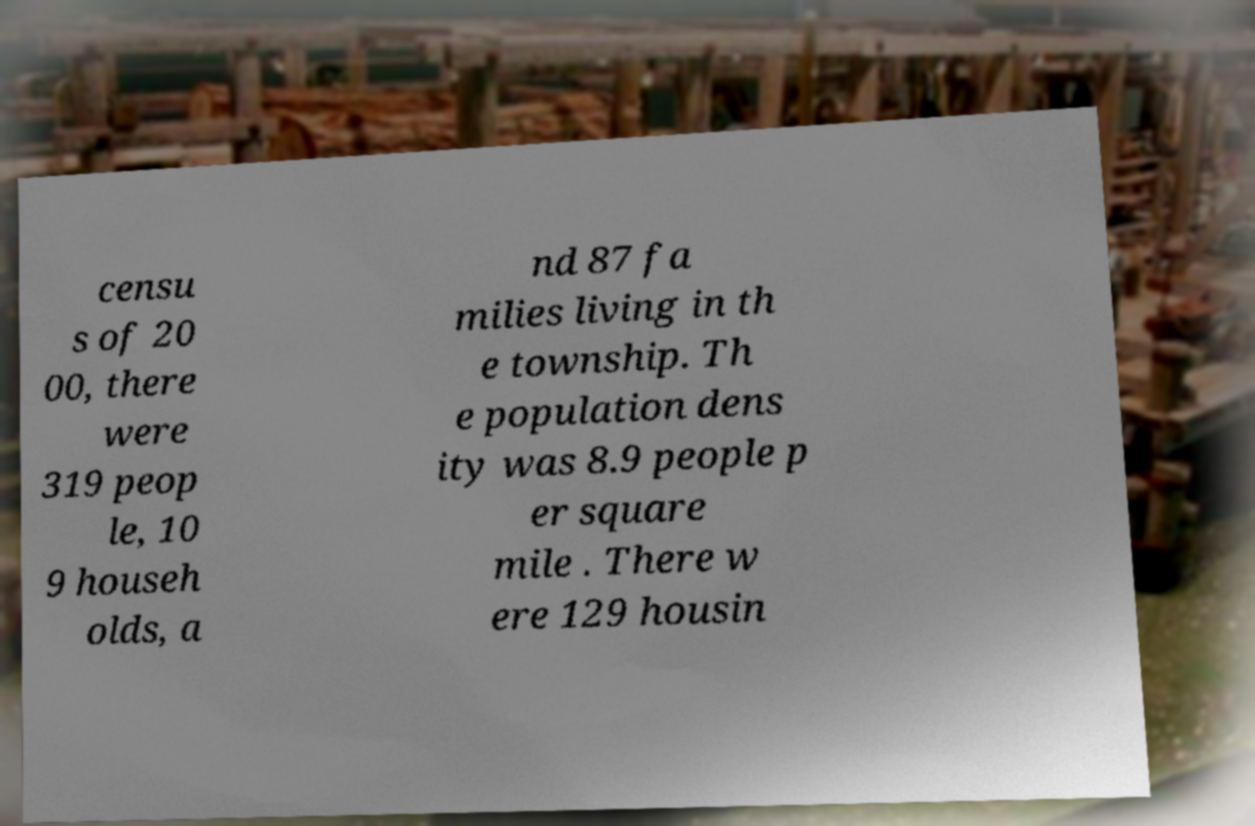Can you read and provide the text displayed in the image?This photo seems to have some interesting text. Can you extract and type it out for me? censu s of 20 00, there were 319 peop le, 10 9 househ olds, a nd 87 fa milies living in th e township. Th e population dens ity was 8.9 people p er square mile . There w ere 129 housin 